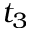Convert formula to latex. <formula><loc_0><loc_0><loc_500><loc_500>t _ { 3 }</formula> 